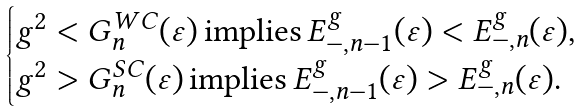Convert formula to latex. <formula><loc_0><loc_0><loc_500><loc_500>\begin{cases} g ^ { 2 } < G _ { n } ^ { W C } ( \varepsilon ) \, \text {implies} \, E _ { - , n - 1 } ^ { g } ( \varepsilon ) < E _ { - , n } ^ { g } ( \varepsilon ) , \\ g ^ { 2 } > G _ { n } ^ { S C } ( \varepsilon ) \, \text {implies} \, E _ { - , n - 1 } ^ { g } ( \varepsilon ) > E _ { - , n } ^ { g } ( \varepsilon ) . \end{cases}</formula> 